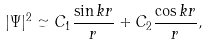Convert formula to latex. <formula><loc_0><loc_0><loc_500><loc_500>| \Psi | ^ { 2 } \simeq C _ { 1 } \frac { \sin k r } { r } + C _ { 2 } \frac { \cos k r } { r } ,</formula> 